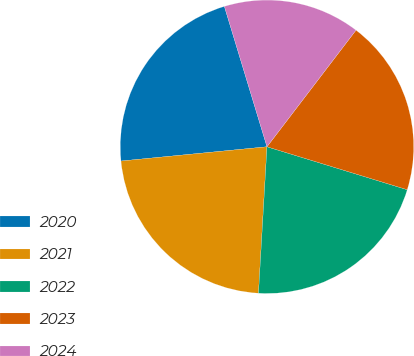Convert chart to OTSL. <chart><loc_0><loc_0><loc_500><loc_500><pie_chart><fcel>2020<fcel>2021<fcel>2022<fcel>2023<fcel>2024<nl><fcel>21.86%<fcel>22.53%<fcel>21.19%<fcel>19.35%<fcel>15.07%<nl></chart> 